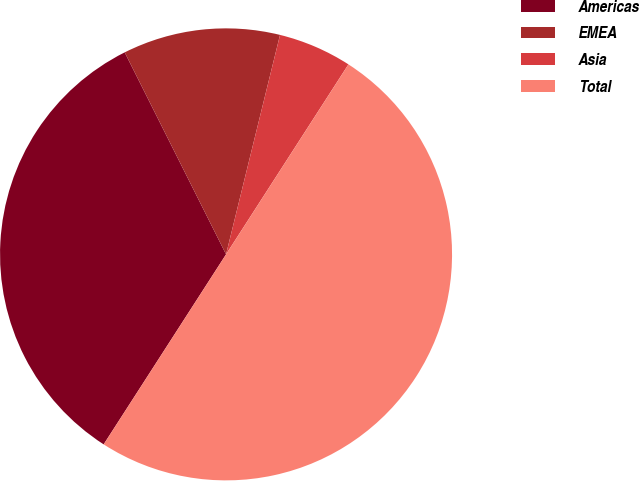Convert chart. <chart><loc_0><loc_0><loc_500><loc_500><pie_chart><fcel>Americas<fcel>EMEA<fcel>Asia<fcel>Total<nl><fcel>33.49%<fcel>11.24%<fcel>5.27%<fcel>50.0%<nl></chart> 